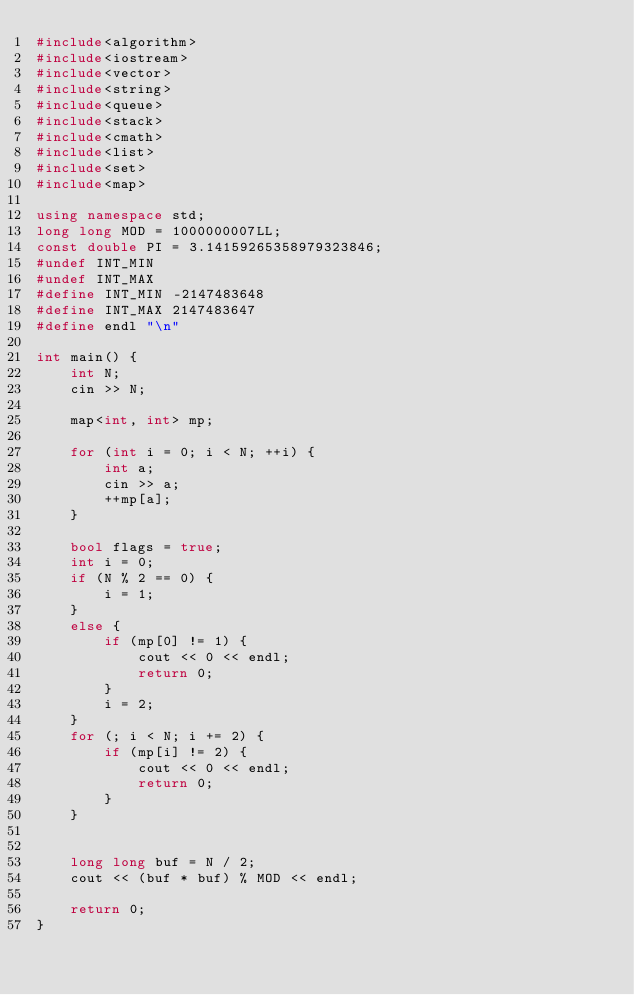Convert code to text. <code><loc_0><loc_0><loc_500><loc_500><_C++_>#include<algorithm>
#include<iostream>
#include<vector>
#include<string>
#include<queue>
#include<stack>
#include<cmath>
#include<list>
#include<set>
#include<map>

using namespace std;
long long MOD = 1000000007LL;
const double PI = 3.14159265358979323846;
#undef INT_MIN
#undef INT_MAX
#define INT_MIN -2147483648
#define INT_MAX 2147483647
#define endl "\n"

int main() {
	int N;
	cin >> N;
	
	map<int, int> mp;

	for (int i = 0; i < N; ++i) {
		int a;
		cin >> a;
		++mp[a];
	}

	bool flags = true;
	int i = 0;
	if (N % 2 == 0) {
		i = 1;
	}
	else {
		if (mp[0] != 1) {
			cout << 0 << endl;
			return 0;
		}
		i = 2;
	}
	for (; i < N; i += 2) {
		if (mp[i] != 2) {
			cout << 0 << endl;
			return 0;
		}
	}


	long long buf = N / 2;
	cout << (buf * buf) % MOD << endl;

	return 0;
}</code> 